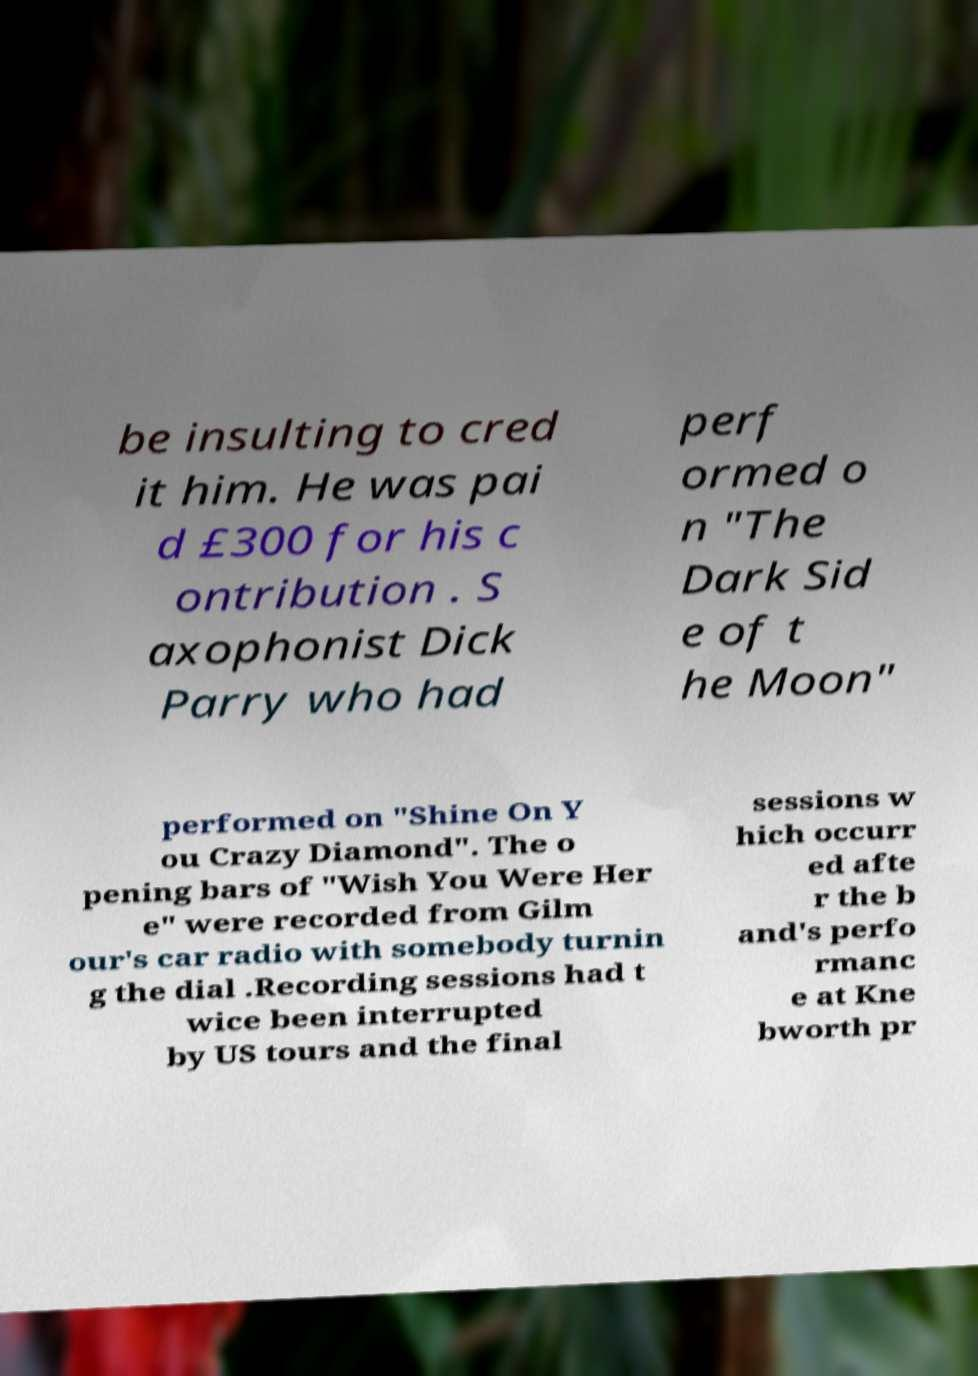Please identify and transcribe the text found in this image. be insulting to cred it him. He was pai d £300 for his c ontribution . S axophonist Dick Parry who had perf ormed o n "The Dark Sid e of t he Moon" performed on "Shine On Y ou Crazy Diamond". The o pening bars of "Wish You Were Her e" were recorded from Gilm our's car radio with somebody turnin g the dial .Recording sessions had t wice been interrupted by US tours and the final sessions w hich occurr ed afte r the b and's perfo rmanc e at Kne bworth pr 